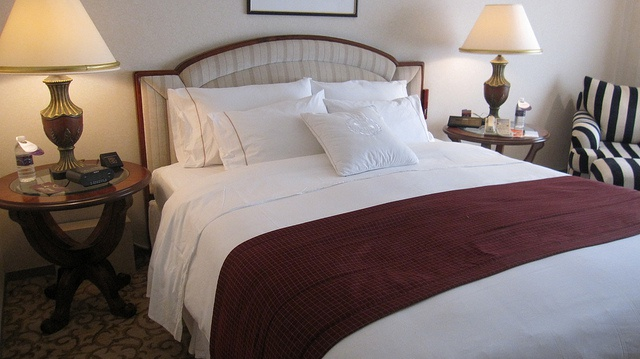Describe the objects in this image and their specific colors. I can see bed in gray, darkgray, black, maroon, and lightgray tones, chair in gray, black, and darkgray tones, bottle in gray, brown, and tan tones, clock in gray, black, and maroon tones, and bottle in gray, darkgray, and lightgray tones in this image. 